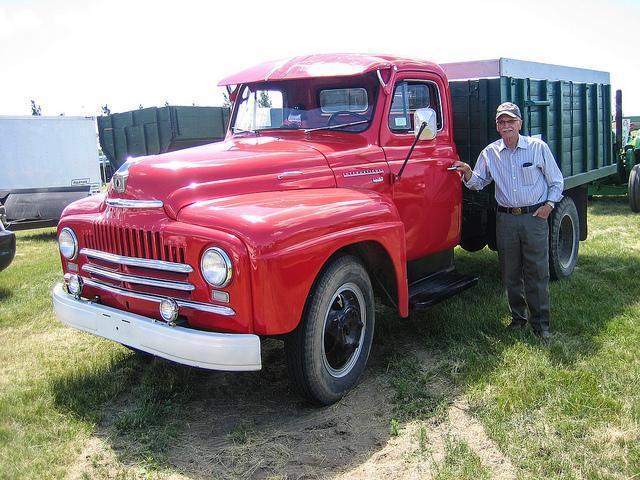How many people are standing beside the truck?
Give a very brief answer. 1. How many people are in the picture?
Give a very brief answer. 1. How many trucks can you see?
Give a very brief answer. 2. 